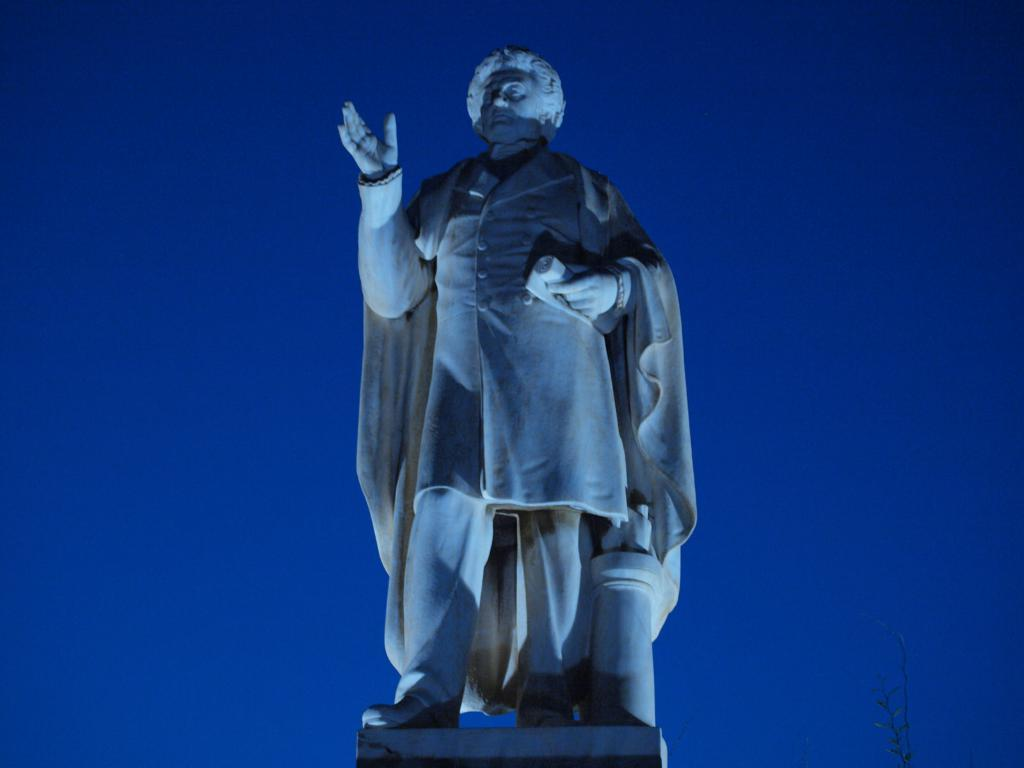Where was the image taken? The image was taken outdoors. What can be seen in the background of the image? There is a sky visible in the background of the image. What is the main subject in the middle of the image? There is a statue of a man in the middle of the image. What type of ice is being used to make the selection in the image? There is no ice or selection process present in the image; it features a statue of a man outdoors with a visible sky in the background. 